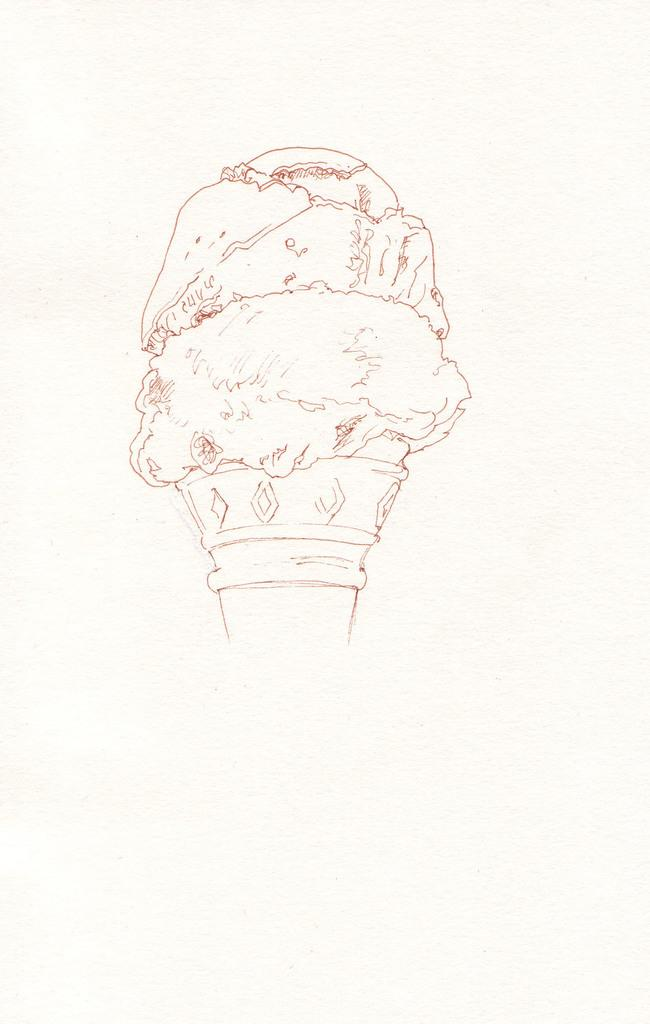What is depicted in the image? There is an art of ice cream in the image. What is the medium of the art? The art is on a piece of paper. What is the artist's belief about the role of ice cream in society, as depicted in the image? The image does not provide any information about the artist's beliefs or the role of ice cream in society. 